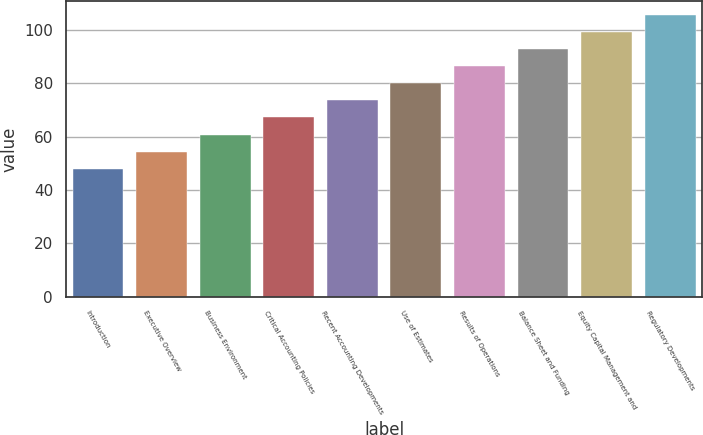Convert chart to OTSL. <chart><loc_0><loc_0><loc_500><loc_500><bar_chart><fcel>Introduction<fcel>Executive Overview<fcel>Business Environment<fcel>Critical Accounting Policies<fcel>Recent Accounting Developments<fcel>Use of Estimates<fcel>Results of Operations<fcel>Balance Sheet and Funding<fcel>Equity Capital Management and<fcel>Regulatory Developments<nl><fcel>48<fcel>54.4<fcel>60.8<fcel>67.2<fcel>73.6<fcel>80<fcel>86.4<fcel>92.8<fcel>99.2<fcel>105.6<nl></chart> 